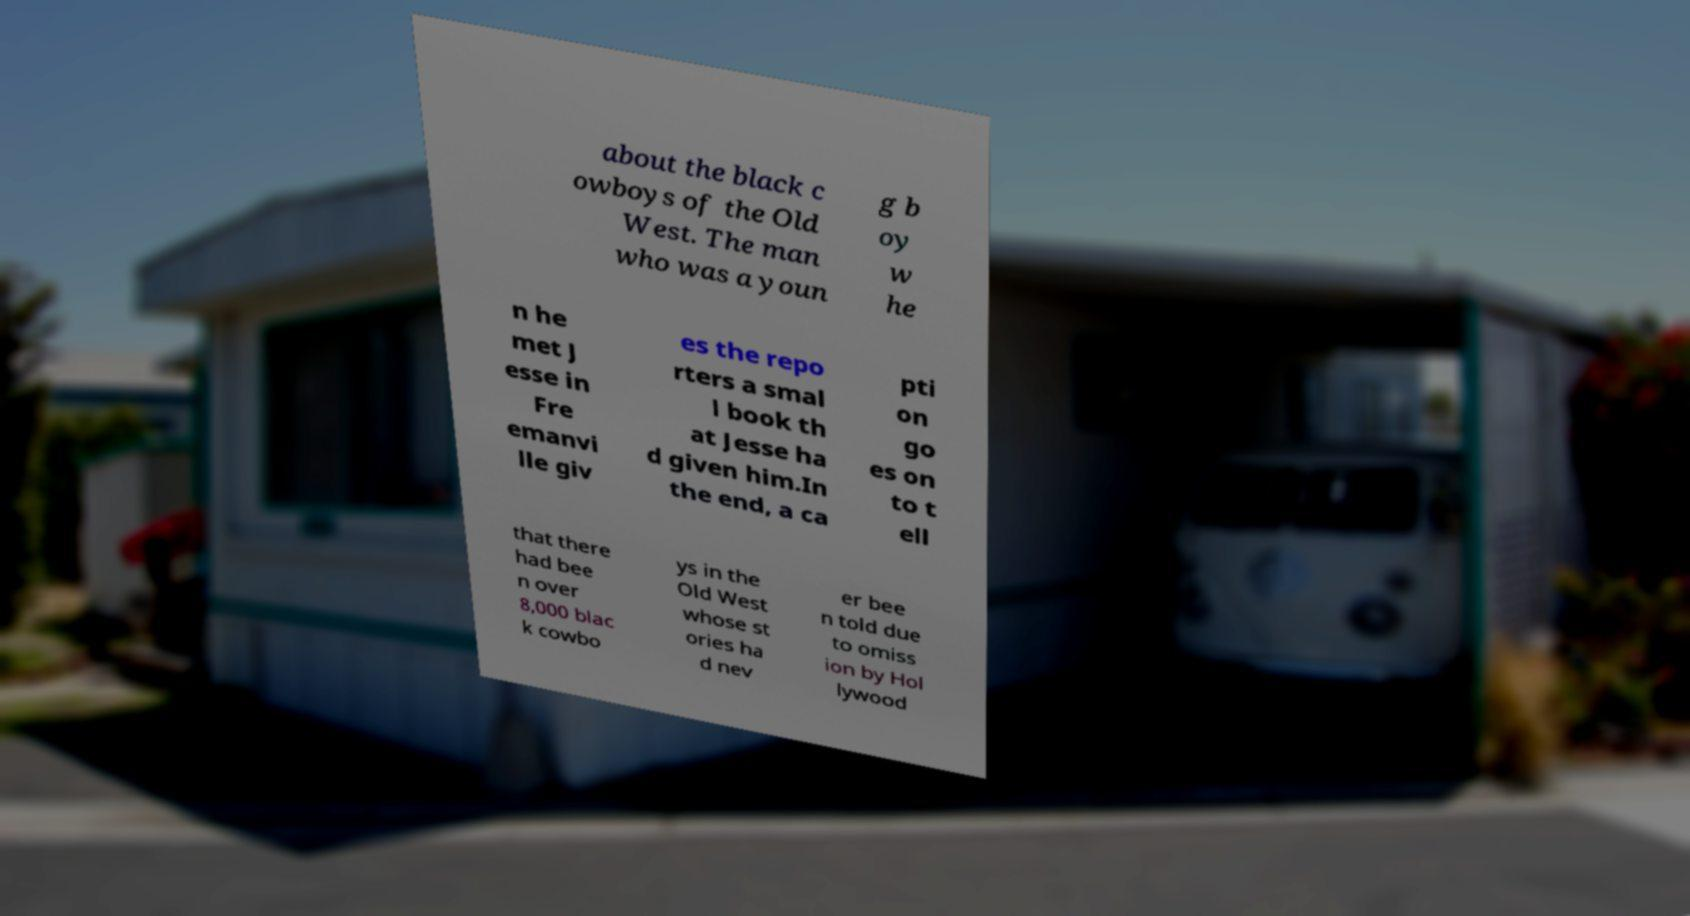I need the written content from this picture converted into text. Can you do that? about the black c owboys of the Old West. The man who was a youn g b oy w he n he met J esse in Fre emanvi lle giv es the repo rters a smal l book th at Jesse ha d given him.In the end, a ca pti on go es on to t ell that there had bee n over 8,000 blac k cowbo ys in the Old West whose st ories ha d nev er bee n told due to omiss ion by Hol lywood 